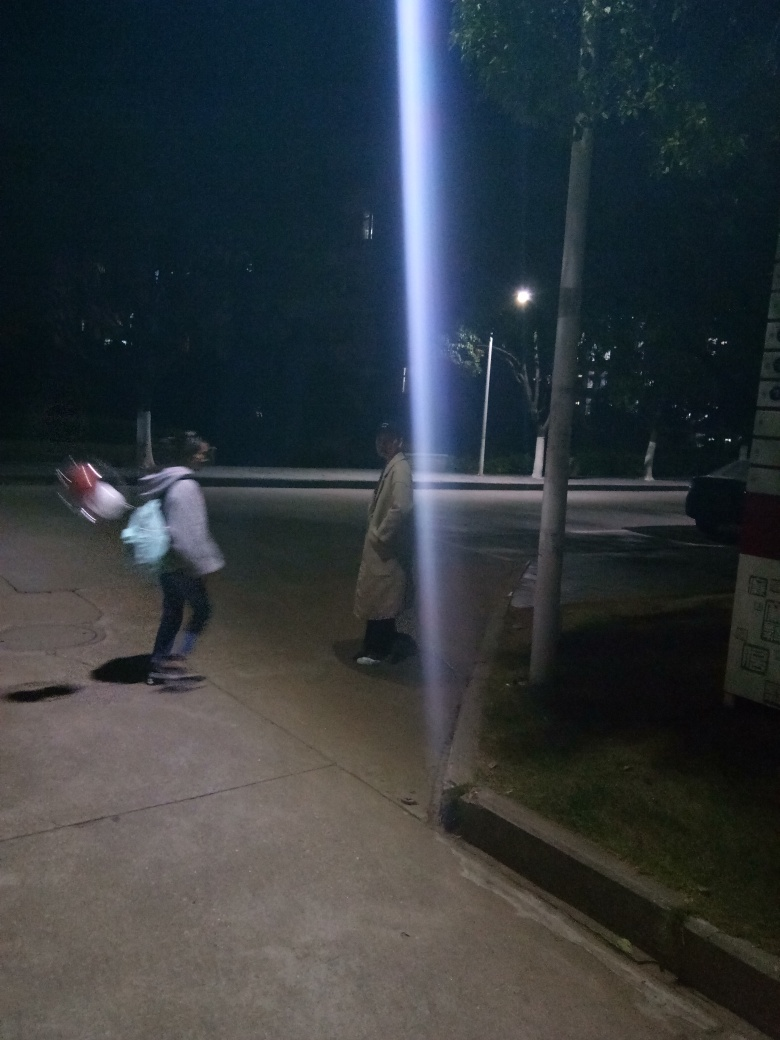What could be the reason for the vertical light streak in the image? The vertical light streak in the image could be the result of a bright source of light, such as a streetlamp, directly facing the camera. This might not be an element present in the scene itself but rather a photographic artifact known as lens flare, which occurs when light scatters within a camera lens. 